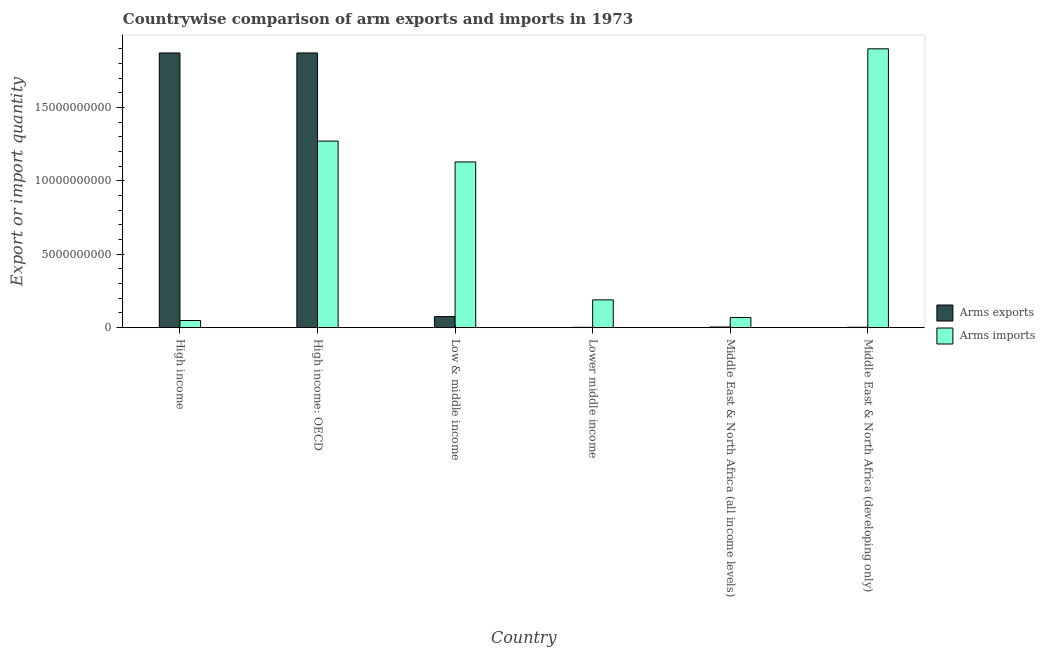How many different coloured bars are there?
Offer a terse response. 2. How many groups of bars are there?
Ensure brevity in your answer.  6. Are the number of bars on each tick of the X-axis equal?
Your answer should be very brief. Yes. How many bars are there on the 5th tick from the right?
Ensure brevity in your answer.  2. What is the label of the 6th group of bars from the left?
Give a very brief answer. Middle East & North Africa (developing only). In how many cases, is the number of bars for a given country not equal to the number of legend labels?
Provide a short and direct response. 0. What is the arms exports in Middle East & North Africa (developing only)?
Provide a succinct answer. 2.80e+07. Across all countries, what is the maximum arms exports?
Keep it short and to the point. 1.87e+1. Across all countries, what is the minimum arms imports?
Give a very brief answer. 4.88e+08. What is the total arms imports in the graph?
Your answer should be compact. 4.61e+1. What is the difference between the arms exports in High income: OECD and that in Low & middle income?
Your answer should be compact. 1.80e+1. What is the difference between the arms exports in Lower middle income and the arms imports in Middle East & North Africa (all income levels)?
Your answer should be compact. -6.72e+08. What is the average arms exports per country?
Your answer should be compact. 6.38e+09. What is the difference between the arms exports and arms imports in Low & middle income?
Ensure brevity in your answer.  -1.05e+1. In how many countries, is the arms exports greater than 14000000000 ?
Make the answer very short. 2. What is the ratio of the arms exports in High income: OECD to that in Lower middle income?
Provide a short and direct response. 891.48. Is the arms exports in High income less than that in High income: OECD?
Provide a short and direct response. No. Is the difference between the arms imports in High income: OECD and Lower middle income greater than the difference between the arms exports in High income: OECD and Lower middle income?
Give a very brief answer. No. What is the difference between the highest and the second highest arms imports?
Make the answer very short. 6.29e+09. What is the difference between the highest and the lowest arms exports?
Your response must be concise. 1.87e+1. In how many countries, is the arms imports greater than the average arms imports taken over all countries?
Provide a short and direct response. 3. What does the 1st bar from the left in Lower middle income represents?
Provide a short and direct response. Arms exports. What does the 2nd bar from the right in High income represents?
Provide a short and direct response. Arms exports. Are all the bars in the graph horizontal?
Keep it short and to the point. No. Are the values on the major ticks of Y-axis written in scientific E-notation?
Ensure brevity in your answer.  No. Does the graph contain grids?
Your answer should be compact. No. Where does the legend appear in the graph?
Your answer should be compact. Center right. How are the legend labels stacked?
Keep it short and to the point. Vertical. What is the title of the graph?
Offer a terse response. Countrywise comparison of arm exports and imports in 1973. Does "Fraud firms" appear as one of the legend labels in the graph?
Make the answer very short. No. What is the label or title of the Y-axis?
Your response must be concise. Export or import quantity. What is the Export or import quantity in Arms exports in High income?
Your response must be concise. 1.87e+1. What is the Export or import quantity of Arms imports in High income?
Your answer should be compact. 4.88e+08. What is the Export or import quantity in Arms exports in High income: OECD?
Provide a short and direct response. 1.87e+1. What is the Export or import quantity in Arms imports in High income: OECD?
Your answer should be compact. 1.27e+1. What is the Export or import quantity of Arms exports in Low & middle income?
Your answer should be compact. 7.55e+08. What is the Export or import quantity of Arms imports in Low & middle income?
Make the answer very short. 1.13e+1. What is the Export or import quantity in Arms exports in Lower middle income?
Your answer should be compact. 2.10e+07. What is the Export or import quantity in Arms imports in Lower middle income?
Your response must be concise. 1.89e+09. What is the Export or import quantity in Arms exports in Middle East & North Africa (all income levels)?
Make the answer very short. 4.50e+07. What is the Export or import quantity in Arms imports in Middle East & North Africa (all income levels)?
Ensure brevity in your answer.  6.93e+08. What is the Export or import quantity of Arms exports in Middle East & North Africa (developing only)?
Your answer should be very brief. 2.80e+07. What is the Export or import quantity of Arms imports in Middle East & North Africa (developing only)?
Provide a succinct answer. 1.90e+1. Across all countries, what is the maximum Export or import quantity in Arms exports?
Your answer should be very brief. 1.87e+1. Across all countries, what is the maximum Export or import quantity of Arms imports?
Your answer should be compact. 1.90e+1. Across all countries, what is the minimum Export or import quantity of Arms exports?
Keep it short and to the point. 2.10e+07. Across all countries, what is the minimum Export or import quantity of Arms imports?
Make the answer very short. 4.88e+08. What is the total Export or import quantity in Arms exports in the graph?
Ensure brevity in your answer.  3.83e+1. What is the total Export or import quantity of Arms imports in the graph?
Your answer should be very brief. 4.61e+1. What is the difference between the Export or import quantity in Arms exports in High income and that in High income: OECD?
Make the answer very short. 0. What is the difference between the Export or import quantity of Arms imports in High income and that in High income: OECD?
Provide a short and direct response. -1.22e+1. What is the difference between the Export or import quantity in Arms exports in High income and that in Low & middle income?
Offer a terse response. 1.80e+1. What is the difference between the Export or import quantity in Arms imports in High income and that in Low & middle income?
Make the answer very short. -1.08e+1. What is the difference between the Export or import quantity of Arms exports in High income and that in Lower middle income?
Provide a short and direct response. 1.87e+1. What is the difference between the Export or import quantity of Arms imports in High income and that in Lower middle income?
Provide a succinct answer. -1.41e+09. What is the difference between the Export or import quantity in Arms exports in High income and that in Middle East & North Africa (all income levels)?
Make the answer very short. 1.87e+1. What is the difference between the Export or import quantity in Arms imports in High income and that in Middle East & North Africa (all income levels)?
Offer a terse response. -2.05e+08. What is the difference between the Export or import quantity of Arms exports in High income and that in Middle East & North Africa (developing only)?
Provide a short and direct response. 1.87e+1. What is the difference between the Export or import quantity of Arms imports in High income and that in Middle East & North Africa (developing only)?
Your answer should be very brief. -1.85e+1. What is the difference between the Export or import quantity in Arms exports in High income: OECD and that in Low & middle income?
Your answer should be compact. 1.80e+1. What is the difference between the Export or import quantity of Arms imports in High income: OECD and that in Low & middle income?
Ensure brevity in your answer.  1.42e+09. What is the difference between the Export or import quantity in Arms exports in High income: OECD and that in Lower middle income?
Provide a succinct answer. 1.87e+1. What is the difference between the Export or import quantity of Arms imports in High income: OECD and that in Lower middle income?
Your answer should be compact. 1.08e+1. What is the difference between the Export or import quantity in Arms exports in High income: OECD and that in Middle East & North Africa (all income levels)?
Offer a terse response. 1.87e+1. What is the difference between the Export or import quantity of Arms imports in High income: OECD and that in Middle East & North Africa (all income levels)?
Your answer should be very brief. 1.20e+1. What is the difference between the Export or import quantity in Arms exports in High income: OECD and that in Middle East & North Africa (developing only)?
Provide a succinct answer. 1.87e+1. What is the difference between the Export or import quantity in Arms imports in High income: OECD and that in Middle East & North Africa (developing only)?
Keep it short and to the point. -6.29e+09. What is the difference between the Export or import quantity of Arms exports in Low & middle income and that in Lower middle income?
Offer a very short reply. 7.34e+08. What is the difference between the Export or import quantity of Arms imports in Low & middle income and that in Lower middle income?
Your answer should be compact. 9.40e+09. What is the difference between the Export or import quantity in Arms exports in Low & middle income and that in Middle East & North Africa (all income levels)?
Ensure brevity in your answer.  7.10e+08. What is the difference between the Export or import quantity in Arms imports in Low & middle income and that in Middle East & North Africa (all income levels)?
Your answer should be very brief. 1.06e+1. What is the difference between the Export or import quantity of Arms exports in Low & middle income and that in Middle East & North Africa (developing only)?
Ensure brevity in your answer.  7.27e+08. What is the difference between the Export or import quantity of Arms imports in Low & middle income and that in Middle East & North Africa (developing only)?
Offer a terse response. -7.71e+09. What is the difference between the Export or import quantity in Arms exports in Lower middle income and that in Middle East & North Africa (all income levels)?
Give a very brief answer. -2.40e+07. What is the difference between the Export or import quantity of Arms imports in Lower middle income and that in Middle East & North Africa (all income levels)?
Ensure brevity in your answer.  1.20e+09. What is the difference between the Export or import quantity of Arms exports in Lower middle income and that in Middle East & North Africa (developing only)?
Your answer should be compact. -7.00e+06. What is the difference between the Export or import quantity of Arms imports in Lower middle income and that in Middle East & North Africa (developing only)?
Give a very brief answer. -1.71e+1. What is the difference between the Export or import quantity in Arms exports in Middle East & North Africa (all income levels) and that in Middle East & North Africa (developing only)?
Your response must be concise. 1.70e+07. What is the difference between the Export or import quantity in Arms imports in Middle East & North Africa (all income levels) and that in Middle East & North Africa (developing only)?
Your response must be concise. -1.83e+1. What is the difference between the Export or import quantity of Arms exports in High income and the Export or import quantity of Arms imports in High income: OECD?
Provide a short and direct response. 6.01e+09. What is the difference between the Export or import quantity in Arms exports in High income and the Export or import quantity in Arms imports in Low & middle income?
Ensure brevity in your answer.  7.43e+09. What is the difference between the Export or import quantity of Arms exports in High income and the Export or import quantity of Arms imports in Lower middle income?
Your answer should be compact. 1.68e+1. What is the difference between the Export or import quantity in Arms exports in High income and the Export or import quantity in Arms imports in Middle East & North Africa (all income levels)?
Your answer should be very brief. 1.80e+1. What is the difference between the Export or import quantity in Arms exports in High income and the Export or import quantity in Arms imports in Middle East & North Africa (developing only)?
Offer a very short reply. -2.82e+08. What is the difference between the Export or import quantity in Arms exports in High income: OECD and the Export or import quantity in Arms imports in Low & middle income?
Ensure brevity in your answer.  7.43e+09. What is the difference between the Export or import quantity of Arms exports in High income: OECD and the Export or import quantity of Arms imports in Lower middle income?
Provide a short and direct response. 1.68e+1. What is the difference between the Export or import quantity of Arms exports in High income: OECD and the Export or import quantity of Arms imports in Middle East & North Africa (all income levels)?
Provide a succinct answer. 1.80e+1. What is the difference between the Export or import quantity in Arms exports in High income: OECD and the Export or import quantity in Arms imports in Middle East & North Africa (developing only)?
Provide a short and direct response. -2.82e+08. What is the difference between the Export or import quantity in Arms exports in Low & middle income and the Export or import quantity in Arms imports in Lower middle income?
Your response must be concise. -1.14e+09. What is the difference between the Export or import quantity of Arms exports in Low & middle income and the Export or import quantity of Arms imports in Middle East & North Africa (all income levels)?
Your answer should be very brief. 6.20e+07. What is the difference between the Export or import quantity of Arms exports in Low & middle income and the Export or import quantity of Arms imports in Middle East & North Africa (developing only)?
Offer a terse response. -1.82e+1. What is the difference between the Export or import quantity of Arms exports in Lower middle income and the Export or import quantity of Arms imports in Middle East & North Africa (all income levels)?
Give a very brief answer. -6.72e+08. What is the difference between the Export or import quantity in Arms exports in Lower middle income and the Export or import quantity in Arms imports in Middle East & North Africa (developing only)?
Offer a terse response. -1.90e+1. What is the difference between the Export or import quantity of Arms exports in Middle East & North Africa (all income levels) and the Export or import quantity of Arms imports in Middle East & North Africa (developing only)?
Give a very brief answer. -1.90e+1. What is the average Export or import quantity in Arms exports per country?
Provide a succinct answer. 6.38e+09. What is the average Export or import quantity of Arms imports per country?
Provide a succinct answer. 7.68e+09. What is the difference between the Export or import quantity in Arms exports and Export or import quantity in Arms imports in High income?
Your answer should be very brief. 1.82e+1. What is the difference between the Export or import quantity in Arms exports and Export or import quantity in Arms imports in High income: OECD?
Offer a very short reply. 6.01e+09. What is the difference between the Export or import quantity of Arms exports and Export or import quantity of Arms imports in Low & middle income?
Offer a terse response. -1.05e+1. What is the difference between the Export or import quantity of Arms exports and Export or import quantity of Arms imports in Lower middle income?
Give a very brief answer. -1.87e+09. What is the difference between the Export or import quantity in Arms exports and Export or import quantity in Arms imports in Middle East & North Africa (all income levels)?
Provide a succinct answer. -6.48e+08. What is the difference between the Export or import quantity in Arms exports and Export or import quantity in Arms imports in Middle East & North Africa (developing only)?
Your answer should be compact. -1.90e+1. What is the ratio of the Export or import quantity in Arms exports in High income to that in High income: OECD?
Ensure brevity in your answer.  1. What is the ratio of the Export or import quantity in Arms imports in High income to that in High income: OECD?
Offer a terse response. 0.04. What is the ratio of the Export or import quantity in Arms exports in High income to that in Low & middle income?
Keep it short and to the point. 24.8. What is the ratio of the Export or import quantity in Arms imports in High income to that in Low & middle income?
Give a very brief answer. 0.04. What is the ratio of the Export or import quantity in Arms exports in High income to that in Lower middle income?
Ensure brevity in your answer.  891.48. What is the ratio of the Export or import quantity of Arms imports in High income to that in Lower middle income?
Make the answer very short. 0.26. What is the ratio of the Export or import quantity in Arms exports in High income to that in Middle East & North Africa (all income levels)?
Your answer should be compact. 416.02. What is the ratio of the Export or import quantity in Arms imports in High income to that in Middle East & North Africa (all income levels)?
Your answer should be very brief. 0.7. What is the ratio of the Export or import quantity in Arms exports in High income to that in Middle East & North Africa (developing only)?
Provide a succinct answer. 668.61. What is the ratio of the Export or import quantity in Arms imports in High income to that in Middle East & North Africa (developing only)?
Your answer should be very brief. 0.03. What is the ratio of the Export or import quantity of Arms exports in High income: OECD to that in Low & middle income?
Ensure brevity in your answer.  24.8. What is the ratio of the Export or import quantity in Arms imports in High income: OECD to that in Low & middle income?
Make the answer very short. 1.13. What is the ratio of the Export or import quantity in Arms exports in High income: OECD to that in Lower middle income?
Provide a succinct answer. 891.48. What is the ratio of the Export or import quantity in Arms imports in High income: OECD to that in Lower middle income?
Your response must be concise. 6.71. What is the ratio of the Export or import quantity of Arms exports in High income: OECD to that in Middle East & North Africa (all income levels)?
Make the answer very short. 416.02. What is the ratio of the Export or import quantity of Arms imports in High income: OECD to that in Middle East & North Africa (all income levels)?
Give a very brief answer. 18.35. What is the ratio of the Export or import quantity in Arms exports in High income: OECD to that in Middle East & North Africa (developing only)?
Give a very brief answer. 668.61. What is the ratio of the Export or import quantity in Arms imports in High income: OECD to that in Middle East & North Africa (developing only)?
Offer a terse response. 0.67. What is the ratio of the Export or import quantity of Arms exports in Low & middle income to that in Lower middle income?
Your response must be concise. 35.95. What is the ratio of the Export or import quantity in Arms imports in Low & middle income to that in Lower middle income?
Give a very brief answer. 5.96. What is the ratio of the Export or import quantity of Arms exports in Low & middle income to that in Middle East & North Africa (all income levels)?
Your answer should be very brief. 16.78. What is the ratio of the Export or import quantity in Arms imports in Low & middle income to that in Middle East & North Africa (all income levels)?
Give a very brief answer. 16.3. What is the ratio of the Export or import quantity of Arms exports in Low & middle income to that in Middle East & North Africa (developing only)?
Ensure brevity in your answer.  26.96. What is the ratio of the Export or import quantity in Arms imports in Low & middle income to that in Middle East & North Africa (developing only)?
Your answer should be very brief. 0.59. What is the ratio of the Export or import quantity in Arms exports in Lower middle income to that in Middle East & North Africa (all income levels)?
Provide a short and direct response. 0.47. What is the ratio of the Export or import quantity in Arms imports in Lower middle income to that in Middle East & North Africa (all income levels)?
Ensure brevity in your answer.  2.73. What is the ratio of the Export or import quantity of Arms exports in Lower middle income to that in Middle East & North Africa (developing only)?
Make the answer very short. 0.75. What is the ratio of the Export or import quantity of Arms imports in Lower middle income to that in Middle East & North Africa (developing only)?
Give a very brief answer. 0.1. What is the ratio of the Export or import quantity of Arms exports in Middle East & North Africa (all income levels) to that in Middle East & North Africa (developing only)?
Provide a succinct answer. 1.61. What is the ratio of the Export or import quantity in Arms imports in Middle East & North Africa (all income levels) to that in Middle East & North Africa (developing only)?
Offer a terse response. 0.04. What is the difference between the highest and the second highest Export or import quantity of Arms exports?
Offer a terse response. 0. What is the difference between the highest and the second highest Export or import quantity in Arms imports?
Your response must be concise. 6.29e+09. What is the difference between the highest and the lowest Export or import quantity in Arms exports?
Offer a terse response. 1.87e+1. What is the difference between the highest and the lowest Export or import quantity of Arms imports?
Ensure brevity in your answer.  1.85e+1. 